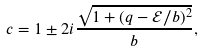<formula> <loc_0><loc_0><loc_500><loc_500>c = 1 \pm 2 i \frac { \sqrt { 1 + ( q - \mathcal { E } / b ) ^ { 2 } } } { b } ,</formula> 